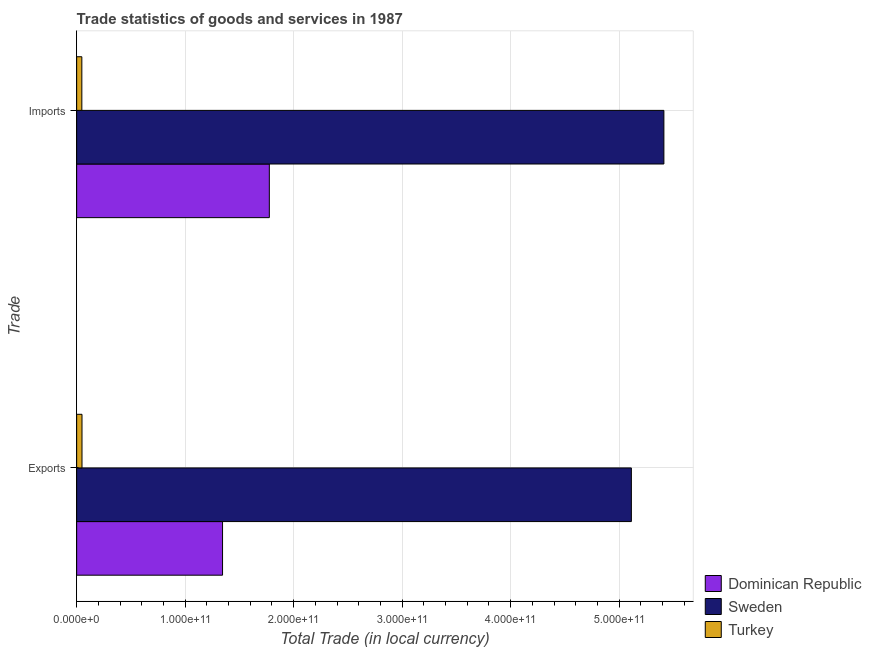How many different coloured bars are there?
Your answer should be compact. 3. Are the number of bars per tick equal to the number of legend labels?
Ensure brevity in your answer.  Yes. Are the number of bars on each tick of the Y-axis equal?
Make the answer very short. Yes. How many bars are there on the 2nd tick from the top?
Give a very brief answer. 3. What is the label of the 1st group of bars from the top?
Ensure brevity in your answer.  Imports. What is the export of goods and services in Dominican Republic?
Offer a terse response. 1.34e+11. Across all countries, what is the maximum export of goods and services?
Keep it short and to the point. 5.11e+11. Across all countries, what is the minimum export of goods and services?
Provide a short and direct response. 4.93e+09. In which country was the imports of goods and services maximum?
Offer a very short reply. Sweden. What is the total export of goods and services in the graph?
Offer a very short reply. 6.51e+11. What is the difference between the export of goods and services in Turkey and that in Dominican Republic?
Provide a short and direct response. -1.30e+11. What is the difference between the imports of goods and services in Turkey and the export of goods and services in Sweden?
Your answer should be compact. -5.06e+11. What is the average export of goods and services per country?
Provide a short and direct response. 2.17e+11. What is the difference between the imports of goods and services and export of goods and services in Sweden?
Offer a terse response. 3.00e+1. What is the ratio of the imports of goods and services in Sweden to that in Turkey?
Make the answer very short. 113.19. In how many countries, is the imports of goods and services greater than the average imports of goods and services taken over all countries?
Provide a short and direct response. 1. What does the 1st bar from the top in Exports represents?
Ensure brevity in your answer.  Turkey. What does the 2nd bar from the bottom in Imports represents?
Give a very brief answer. Sweden. How many bars are there?
Offer a very short reply. 6. Are all the bars in the graph horizontal?
Offer a terse response. Yes. How many countries are there in the graph?
Provide a succinct answer. 3. What is the difference between two consecutive major ticks on the X-axis?
Give a very brief answer. 1.00e+11. Does the graph contain any zero values?
Provide a short and direct response. No. Does the graph contain grids?
Ensure brevity in your answer.  Yes. How many legend labels are there?
Your answer should be very brief. 3. What is the title of the graph?
Offer a terse response. Trade statistics of goods and services in 1987. What is the label or title of the X-axis?
Offer a terse response. Total Trade (in local currency). What is the label or title of the Y-axis?
Your answer should be very brief. Trade. What is the Total Trade (in local currency) of Dominican Republic in Exports?
Keep it short and to the point. 1.34e+11. What is the Total Trade (in local currency) of Sweden in Exports?
Make the answer very short. 5.11e+11. What is the Total Trade (in local currency) of Turkey in Exports?
Offer a very short reply. 4.93e+09. What is the Total Trade (in local currency) of Dominican Republic in Imports?
Ensure brevity in your answer.  1.78e+11. What is the Total Trade (in local currency) in Sweden in Imports?
Offer a very short reply. 5.41e+11. What is the Total Trade (in local currency) in Turkey in Imports?
Your answer should be compact. 4.78e+09. Across all Trade, what is the maximum Total Trade (in local currency) in Dominican Republic?
Your response must be concise. 1.78e+11. Across all Trade, what is the maximum Total Trade (in local currency) of Sweden?
Your answer should be compact. 5.41e+11. Across all Trade, what is the maximum Total Trade (in local currency) of Turkey?
Make the answer very short. 4.93e+09. Across all Trade, what is the minimum Total Trade (in local currency) of Dominican Republic?
Your answer should be very brief. 1.34e+11. Across all Trade, what is the minimum Total Trade (in local currency) in Sweden?
Your answer should be compact. 5.11e+11. Across all Trade, what is the minimum Total Trade (in local currency) of Turkey?
Offer a terse response. 4.78e+09. What is the total Total Trade (in local currency) of Dominican Republic in the graph?
Ensure brevity in your answer.  3.12e+11. What is the total Total Trade (in local currency) in Sweden in the graph?
Provide a short and direct response. 1.05e+12. What is the total Total Trade (in local currency) in Turkey in the graph?
Offer a very short reply. 9.71e+09. What is the difference between the Total Trade (in local currency) in Dominican Republic in Exports and that in Imports?
Your answer should be compact. -4.31e+1. What is the difference between the Total Trade (in local currency) of Sweden in Exports and that in Imports?
Keep it short and to the point. -3.00e+1. What is the difference between the Total Trade (in local currency) of Turkey in Exports and that in Imports?
Your answer should be compact. 1.47e+08. What is the difference between the Total Trade (in local currency) of Dominican Republic in Exports and the Total Trade (in local currency) of Sweden in Imports?
Offer a very short reply. -4.07e+11. What is the difference between the Total Trade (in local currency) in Dominican Republic in Exports and the Total Trade (in local currency) in Turkey in Imports?
Keep it short and to the point. 1.30e+11. What is the difference between the Total Trade (in local currency) of Sweden in Exports and the Total Trade (in local currency) of Turkey in Imports?
Keep it short and to the point. 5.06e+11. What is the average Total Trade (in local currency) of Dominican Republic per Trade?
Make the answer very short. 1.56e+11. What is the average Total Trade (in local currency) of Sweden per Trade?
Ensure brevity in your answer.  5.26e+11. What is the average Total Trade (in local currency) of Turkey per Trade?
Ensure brevity in your answer.  4.86e+09. What is the difference between the Total Trade (in local currency) of Dominican Republic and Total Trade (in local currency) of Sweden in Exports?
Your answer should be very brief. -3.77e+11. What is the difference between the Total Trade (in local currency) in Dominican Republic and Total Trade (in local currency) in Turkey in Exports?
Give a very brief answer. 1.30e+11. What is the difference between the Total Trade (in local currency) of Sweden and Total Trade (in local currency) of Turkey in Exports?
Your answer should be very brief. 5.06e+11. What is the difference between the Total Trade (in local currency) of Dominican Republic and Total Trade (in local currency) of Sweden in Imports?
Provide a succinct answer. -3.64e+11. What is the difference between the Total Trade (in local currency) in Dominican Republic and Total Trade (in local currency) in Turkey in Imports?
Keep it short and to the point. 1.73e+11. What is the difference between the Total Trade (in local currency) in Sweden and Total Trade (in local currency) in Turkey in Imports?
Provide a succinct answer. 5.36e+11. What is the ratio of the Total Trade (in local currency) in Dominican Republic in Exports to that in Imports?
Ensure brevity in your answer.  0.76. What is the ratio of the Total Trade (in local currency) in Sweden in Exports to that in Imports?
Your response must be concise. 0.94. What is the ratio of the Total Trade (in local currency) of Turkey in Exports to that in Imports?
Keep it short and to the point. 1.03. What is the difference between the highest and the second highest Total Trade (in local currency) in Dominican Republic?
Ensure brevity in your answer.  4.31e+1. What is the difference between the highest and the second highest Total Trade (in local currency) in Sweden?
Keep it short and to the point. 3.00e+1. What is the difference between the highest and the second highest Total Trade (in local currency) of Turkey?
Keep it short and to the point. 1.47e+08. What is the difference between the highest and the lowest Total Trade (in local currency) in Dominican Republic?
Offer a very short reply. 4.31e+1. What is the difference between the highest and the lowest Total Trade (in local currency) in Sweden?
Provide a short and direct response. 3.00e+1. What is the difference between the highest and the lowest Total Trade (in local currency) of Turkey?
Keep it short and to the point. 1.47e+08. 